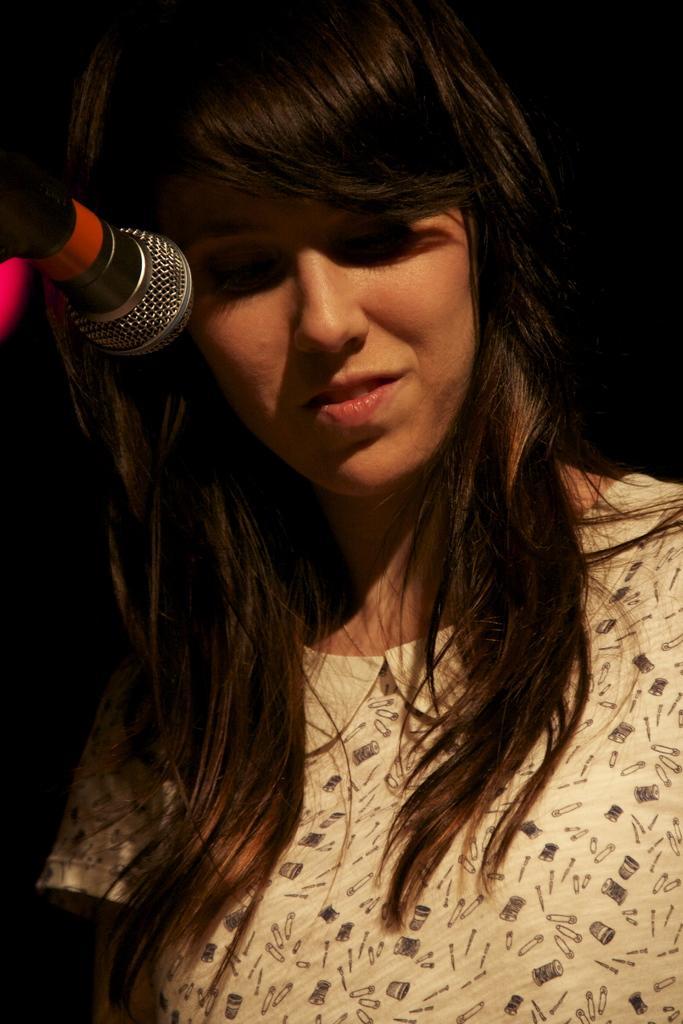Can you describe this image briefly? In this image a lady wearing white dress is standing in front of a mic. 